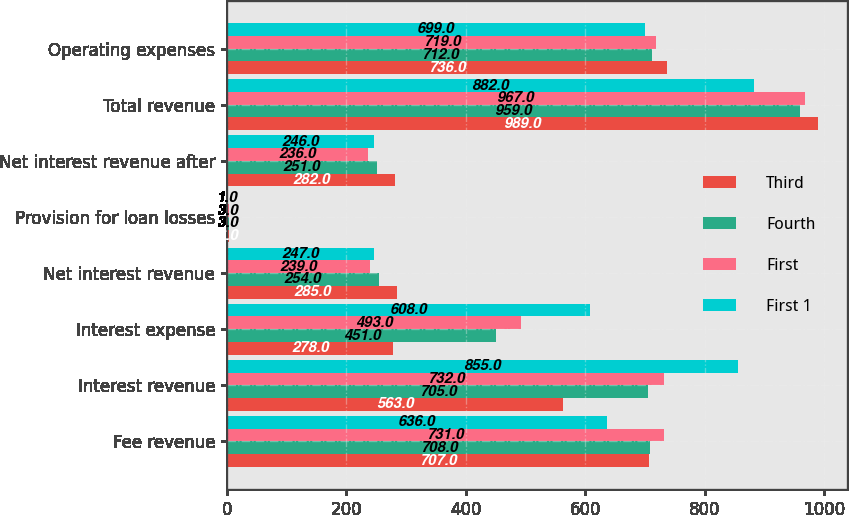<chart> <loc_0><loc_0><loc_500><loc_500><stacked_bar_chart><ecel><fcel>Fee revenue<fcel>Interest revenue<fcel>Interest expense<fcel>Net interest revenue<fcel>Provision for loan losses<fcel>Net interest revenue after<fcel>Total revenue<fcel>Operating expenses<nl><fcel>Third<fcel>707<fcel>563<fcel>278<fcel>285<fcel>3<fcel>282<fcel>989<fcel>736<nl><fcel>Fourth<fcel>708<fcel>705<fcel>451<fcel>254<fcel>3<fcel>251<fcel>959<fcel>712<nl><fcel>First<fcel>731<fcel>732<fcel>493<fcel>239<fcel>3<fcel>236<fcel>967<fcel>719<nl><fcel>First 1<fcel>636<fcel>855<fcel>608<fcel>247<fcel>1<fcel>246<fcel>882<fcel>699<nl></chart> 